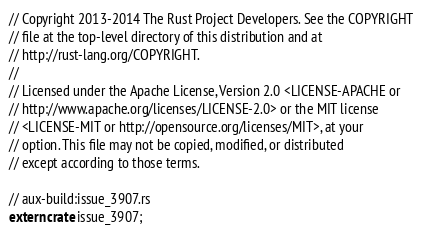<code> <loc_0><loc_0><loc_500><loc_500><_Rust_>// Copyright 2013-2014 The Rust Project Developers. See the COPYRIGHT
// file at the top-level directory of this distribution and at
// http://rust-lang.org/COPYRIGHT.
//
// Licensed under the Apache License, Version 2.0 <LICENSE-APACHE or
// http://www.apache.org/licenses/LICENSE-2.0> or the MIT license
// <LICENSE-MIT or http://opensource.org/licenses/MIT>, at your
// option. This file may not be copied, modified, or distributed
// except according to those terms.

// aux-build:issue_3907.rs
extern crate issue_3907;
</code> 